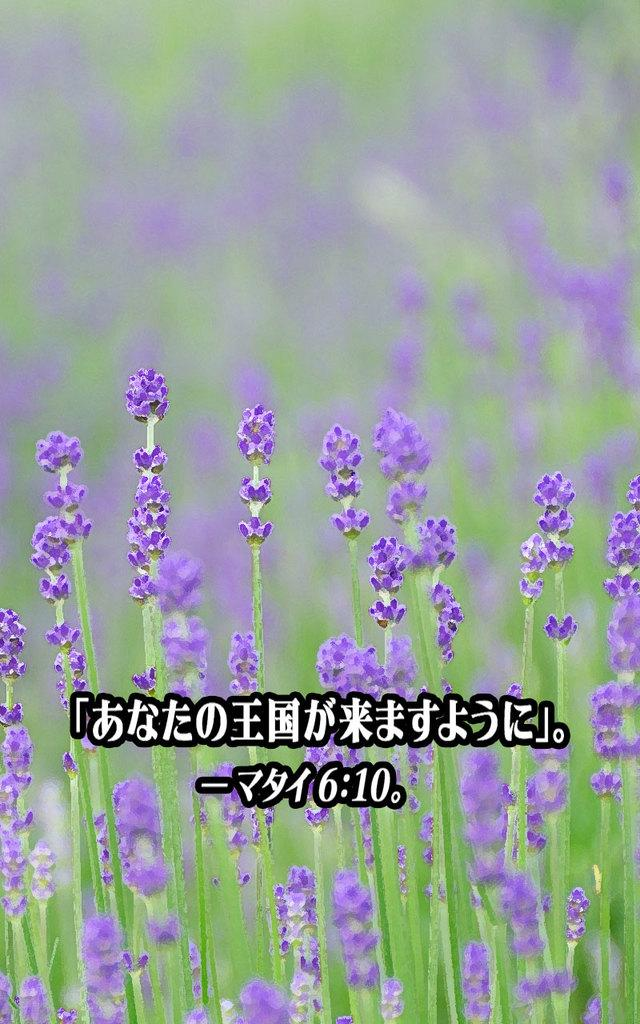What type of plants are visible in the image? There are plants with flowers in the image. Can you describe the background of the image? The background is blurred. Is there any additional information or marking on the image? Yes, there is a watermark on the image. What time of day is represented by the credit on the image? There is no credit or hour mentioned in the image, so it cannot be determined from the image. 